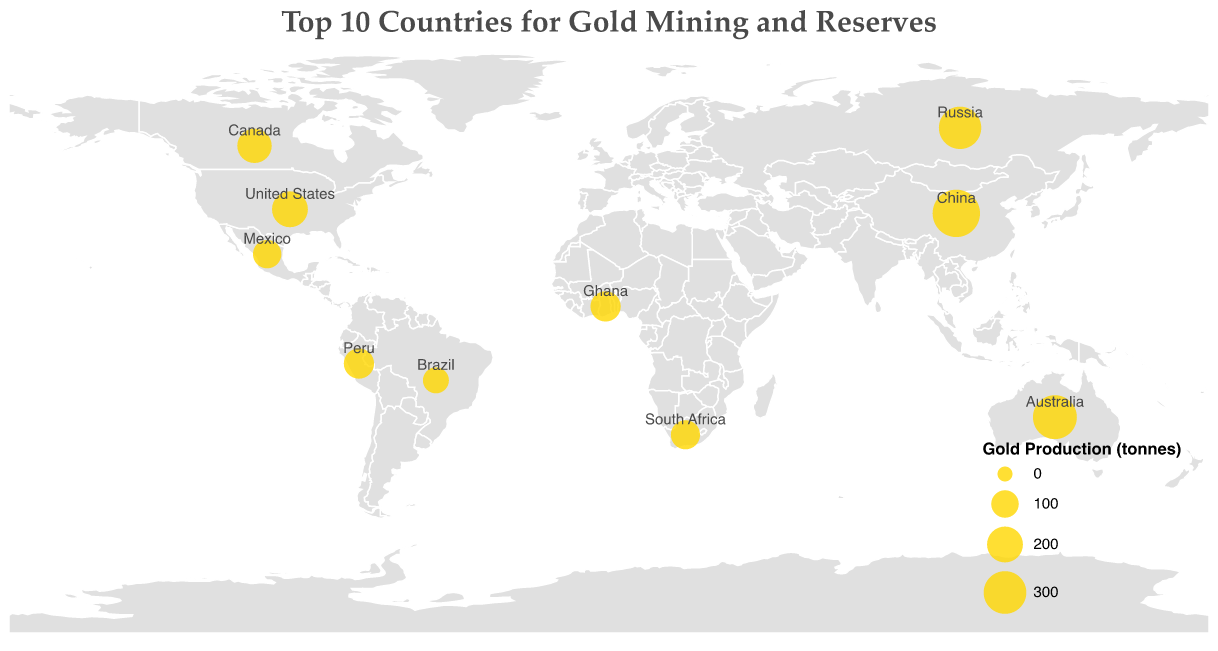Which country has the highest gold production? By inspecting the figure, the size of the circles represents the gold production. The largest circle is located in China. Additionally, when hovering over China, the tooltip shows a gold production of 380 tonnes.
Answer: China What is the total gold production for countries in North America? North America includes the United States, Canada, and Mexico with gold productions of 200, 180, and 110 tonnes, respectively. Summing these values, 200 + 180 + 110 = 490 tonnes.
Answer: 490 tonnes Which country in South America has the most gold reserves? By comparing the gold reserves in the figure's tooltip for South America, Peru has 2600 tonnes and Brazil has 2400 tonnes. Peru has higher gold reserves.
Answer: Peru Which region has the highest total gold reserves among the countries shown? Summing the gold reserves for each region: East Asia (2000), Oceania (10000), Eastern Europe (5500), North America (3000 + 2200 + 1400 = 6600), and Africa (1000 + 3200 = 4200). Oceania has the highest total with 10000 tonnes.
Answer: Oceania What is the average gold production of countries in Africa? Africa includes Ghana and South Africa with gold productions of 130 and 118 tonnes, respectively. The average is calculated as (130 + 118) / 2 = 124 tonnes.
Answer: 124 tonnes Compare the gold reserves of Canada and Brazil. Which country has larger reserves? By looking at the figure, Canada's reserves are 2200 tonnes and Brazil's reserves are 2400 tonnes. Brazil has larger reserves.
Answer: Brazil What is the difference in gold production between the top-producing and the lowest-producing country? The top-producing country is China (380 tonnes) and the lowest-producing country is Brazil (85 tonnes). The difference is 380 - 85 = 295 tonnes.
Answer: 295 tonnes Which country in Oceania is represented, and what are its gold production and reserves? The tooltip for Oceania shows Australia with a gold production of 320 tonnes and reserves of 10000 tonnes.
Answer: Australia, 320 tonnes, 10000 tonnes 